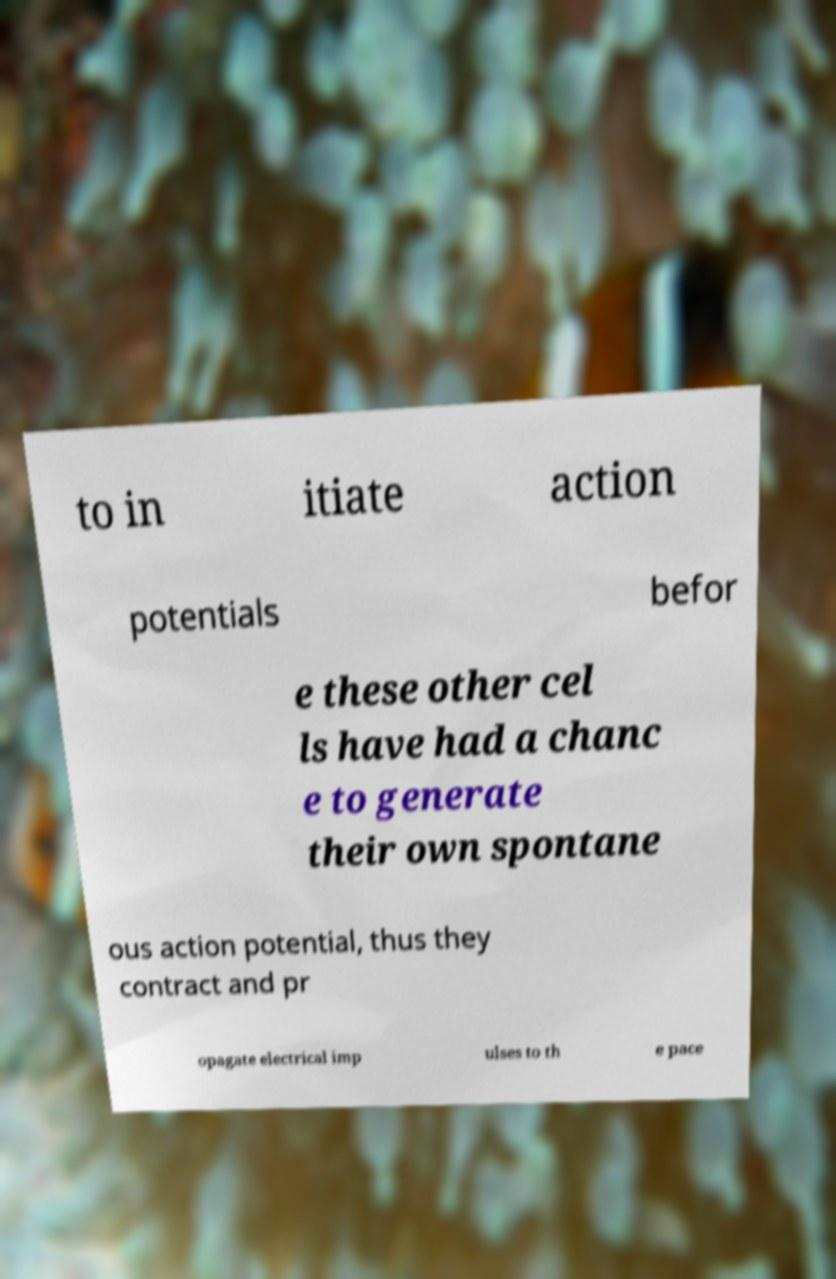Can you read and provide the text displayed in the image?This photo seems to have some interesting text. Can you extract and type it out for me? to in itiate action potentials befor e these other cel ls have had a chanc e to generate their own spontane ous action potential, thus they contract and pr opagate electrical imp ulses to th e pace 